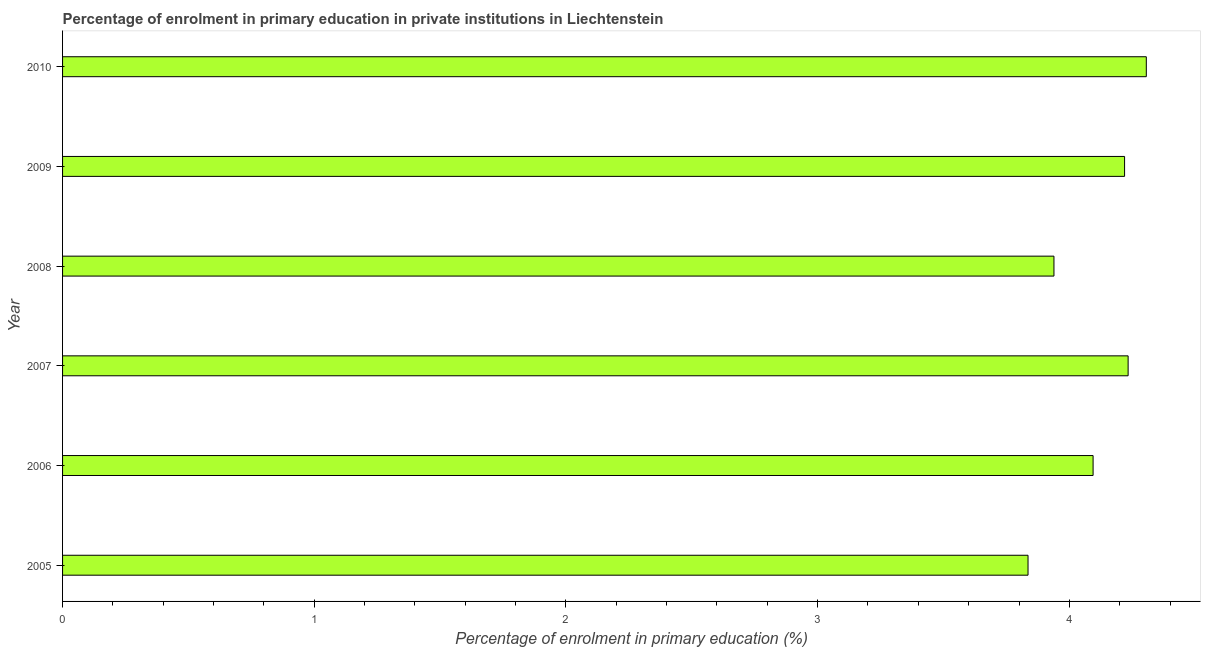Does the graph contain grids?
Your answer should be very brief. No. What is the title of the graph?
Keep it short and to the point. Percentage of enrolment in primary education in private institutions in Liechtenstein. What is the label or title of the X-axis?
Offer a very short reply. Percentage of enrolment in primary education (%). What is the enrolment percentage in primary education in 2008?
Provide a succinct answer. 3.94. Across all years, what is the maximum enrolment percentage in primary education?
Ensure brevity in your answer.  4.31. Across all years, what is the minimum enrolment percentage in primary education?
Offer a terse response. 3.84. What is the sum of the enrolment percentage in primary education?
Give a very brief answer. 24.63. What is the difference between the enrolment percentage in primary education in 2009 and 2010?
Keep it short and to the point. -0.09. What is the average enrolment percentage in primary education per year?
Offer a terse response. 4.11. What is the median enrolment percentage in primary education?
Your answer should be compact. 4.16. In how many years, is the enrolment percentage in primary education greater than 1.6 %?
Offer a terse response. 6. Do a majority of the years between 2007 and 2005 (inclusive) have enrolment percentage in primary education greater than 3.2 %?
Offer a terse response. Yes. What is the difference between the highest and the second highest enrolment percentage in primary education?
Your answer should be compact. 0.07. What is the difference between the highest and the lowest enrolment percentage in primary education?
Provide a succinct answer. 0.47. In how many years, is the enrolment percentage in primary education greater than the average enrolment percentage in primary education taken over all years?
Keep it short and to the point. 3. Are all the bars in the graph horizontal?
Keep it short and to the point. Yes. What is the difference between two consecutive major ticks on the X-axis?
Offer a very short reply. 1. Are the values on the major ticks of X-axis written in scientific E-notation?
Your answer should be very brief. No. What is the Percentage of enrolment in primary education (%) in 2005?
Keep it short and to the point. 3.84. What is the Percentage of enrolment in primary education (%) of 2006?
Give a very brief answer. 4.09. What is the Percentage of enrolment in primary education (%) in 2007?
Ensure brevity in your answer.  4.23. What is the Percentage of enrolment in primary education (%) of 2008?
Give a very brief answer. 3.94. What is the Percentage of enrolment in primary education (%) of 2009?
Provide a succinct answer. 4.22. What is the Percentage of enrolment in primary education (%) of 2010?
Your answer should be compact. 4.31. What is the difference between the Percentage of enrolment in primary education (%) in 2005 and 2006?
Ensure brevity in your answer.  -0.26. What is the difference between the Percentage of enrolment in primary education (%) in 2005 and 2007?
Your response must be concise. -0.4. What is the difference between the Percentage of enrolment in primary education (%) in 2005 and 2008?
Offer a terse response. -0.1. What is the difference between the Percentage of enrolment in primary education (%) in 2005 and 2009?
Ensure brevity in your answer.  -0.38. What is the difference between the Percentage of enrolment in primary education (%) in 2005 and 2010?
Ensure brevity in your answer.  -0.47. What is the difference between the Percentage of enrolment in primary education (%) in 2006 and 2007?
Provide a succinct answer. -0.14. What is the difference between the Percentage of enrolment in primary education (%) in 2006 and 2008?
Your response must be concise. 0.16. What is the difference between the Percentage of enrolment in primary education (%) in 2006 and 2009?
Your response must be concise. -0.13. What is the difference between the Percentage of enrolment in primary education (%) in 2006 and 2010?
Keep it short and to the point. -0.21. What is the difference between the Percentage of enrolment in primary education (%) in 2007 and 2008?
Give a very brief answer. 0.29. What is the difference between the Percentage of enrolment in primary education (%) in 2007 and 2009?
Provide a short and direct response. 0.01. What is the difference between the Percentage of enrolment in primary education (%) in 2007 and 2010?
Your response must be concise. -0.07. What is the difference between the Percentage of enrolment in primary education (%) in 2008 and 2009?
Make the answer very short. -0.28. What is the difference between the Percentage of enrolment in primary education (%) in 2008 and 2010?
Your response must be concise. -0.37. What is the difference between the Percentage of enrolment in primary education (%) in 2009 and 2010?
Give a very brief answer. -0.09. What is the ratio of the Percentage of enrolment in primary education (%) in 2005 to that in 2006?
Make the answer very short. 0.94. What is the ratio of the Percentage of enrolment in primary education (%) in 2005 to that in 2007?
Offer a terse response. 0.91. What is the ratio of the Percentage of enrolment in primary education (%) in 2005 to that in 2009?
Provide a short and direct response. 0.91. What is the ratio of the Percentage of enrolment in primary education (%) in 2005 to that in 2010?
Ensure brevity in your answer.  0.89. What is the ratio of the Percentage of enrolment in primary education (%) in 2006 to that in 2007?
Give a very brief answer. 0.97. What is the ratio of the Percentage of enrolment in primary education (%) in 2006 to that in 2008?
Offer a terse response. 1.04. What is the ratio of the Percentage of enrolment in primary education (%) in 2006 to that in 2010?
Give a very brief answer. 0.95. What is the ratio of the Percentage of enrolment in primary education (%) in 2007 to that in 2008?
Keep it short and to the point. 1.07. What is the ratio of the Percentage of enrolment in primary education (%) in 2007 to that in 2009?
Your answer should be very brief. 1. What is the ratio of the Percentage of enrolment in primary education (%) in 2008 to that in 2009?
Keep it short and to the point. 0.93. What is the ratio of the Percentage of enrolment in primary education (%) in 2008 to that in 2010?
Ensure brevity in your answer.  0.92. What is the ratio of the Percentage of enrolment in primary education (%) in 2009 to that in 2010?
Keep it short and to the point. 0.98. 